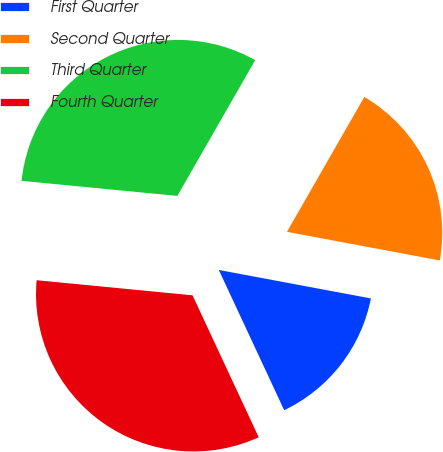<chart> <loc_0><loc_0><loc_500><loc_500><pie_chart><fcel>First Quarter<fcel>Second Quarter<fcel>Third Quarter<fcel>Fourth Quarter<nl><fcel>15.11%<fcel>19.66%<fcel>31.75%<fcel>33.48%<nl></chart> 